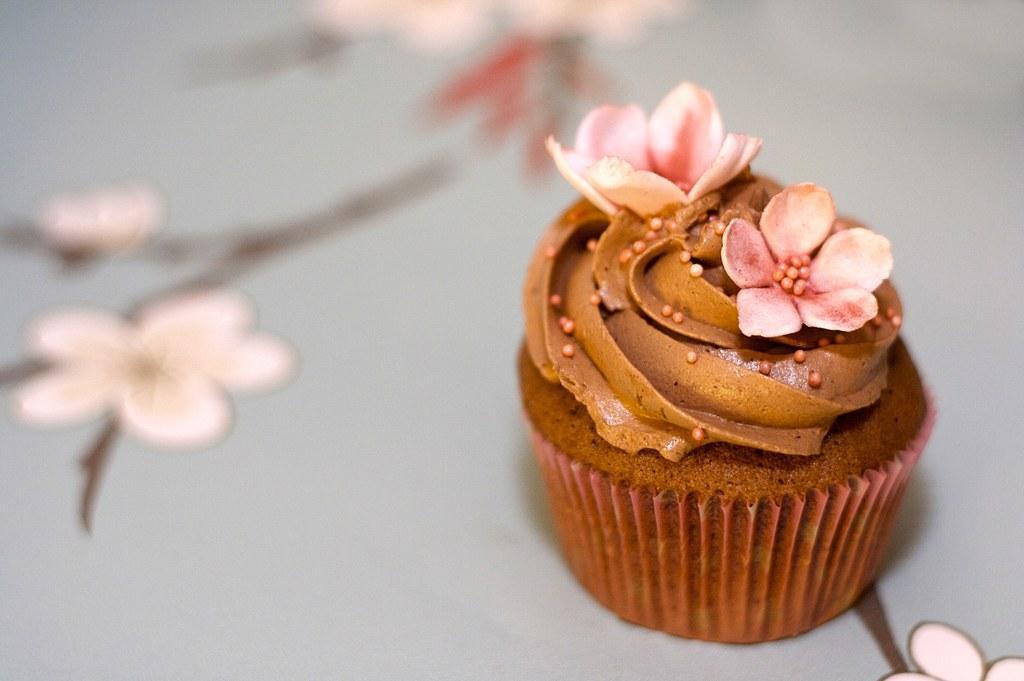Could you give a brief overview of what you see in this image? The picture consists of a cupcake garnished with flowers. The cake is placed on a table, the table has floral designs. 